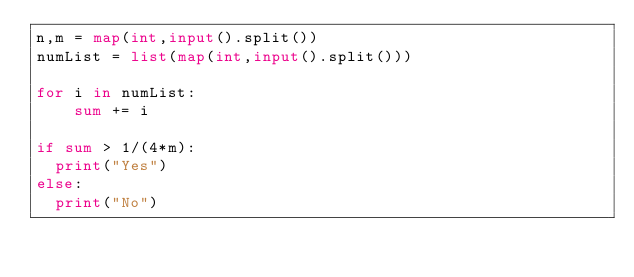<code> <loc_0><loc_0><loc_500><loc_500><_Python_>n,m = map(int,input().split())
numList = list(map(int,input().split()))

for i in numList:
	sum += i

if sum > 1/(4*m):
  print("Yes")
else:
  print("No")
</code> 